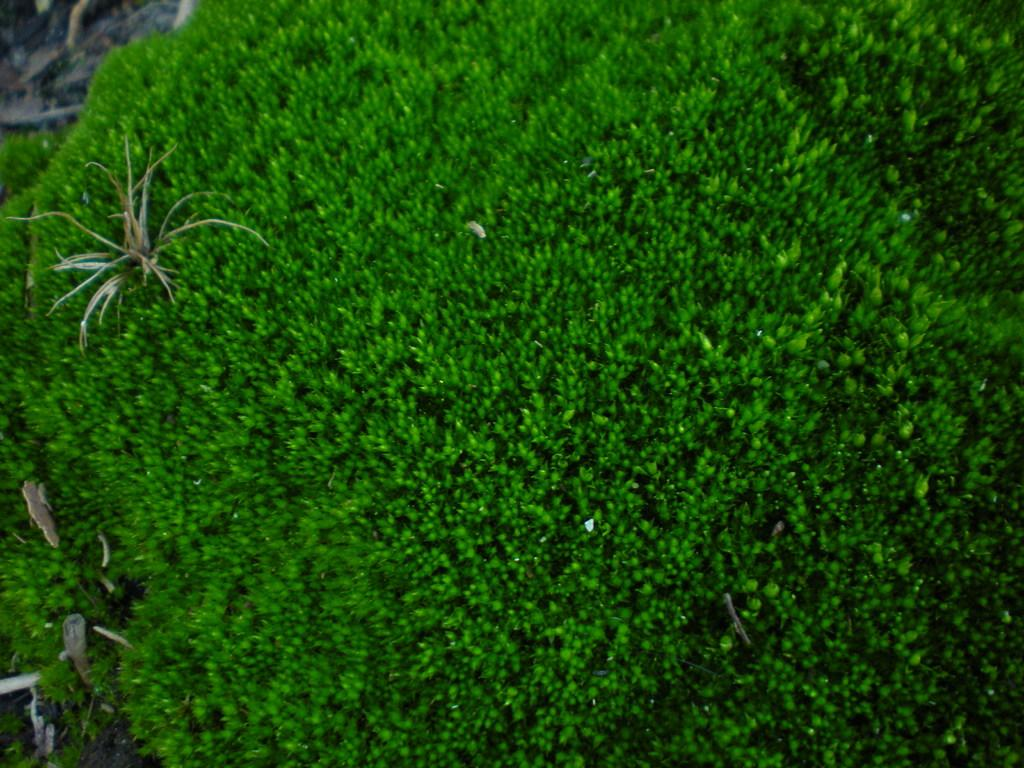What objects are on the ground in the image? There are planets on the ground in the image. What type of rain can be seen falling from the planets in the image? There is no rain present in the image, as it features planets on the ground. What is the purpose of the crate in the image? There is no crate present in the image; it only shows planets on the ground. 